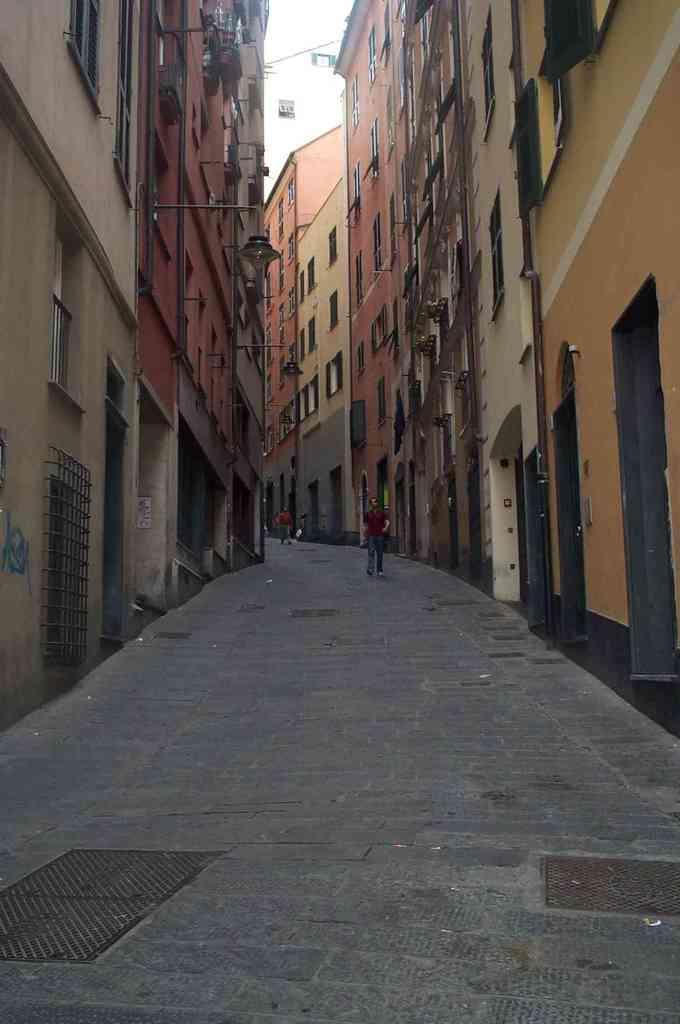How would you summarize this image in a sentence or two? In the picture we can see street, there are some persons walking along the street and we can see some buildings on left and right side of the picture. 